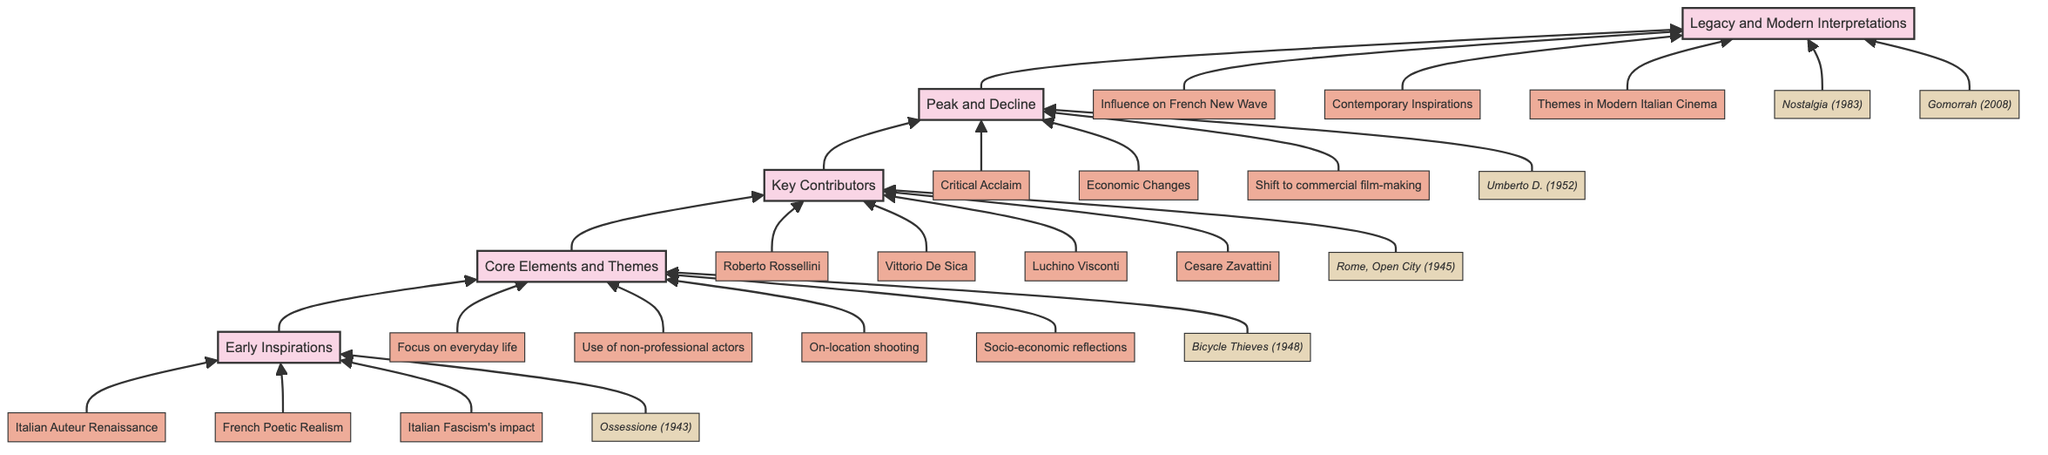What is the starting stage in the diagram? The first node at the bottom of the flow chart is "Early Inspirations," indicating it is the foundational stage for the development of Italian Neorealism.
Answer: Early Inspirations How many core themes are listed under "Core Elements and Themes"? The node "Core Elements and Themes" has four details listed beneath it, which encompass key characteristics of Italian Neorealism.
Answer: 4 Which film is associated with the "Key Contributors" stage? The diagram notes "Rome, Open City" as an example film within the "Key Contributors" stage, linking a specific film to its influential creators.
Answer: Rome, Open City What is the final stage of the described development? The topmost node in the diagram is "Legacy and Modern Interpretations," signifying it as the concluding phase of the flow.
Answer: Legacy and Modern Interpretations Which themes influenced the modern interpretations as noted in the final stage? The final stage underscores three main points: "Influence on French New Wave," "Contemporary Directors Drawing Inspiration," and "Themes in Modern Italian Cinema," indicating the specific thematic legacies of Neorealism.
Answer: Influence on French New Wave, Contemporary Directors Drawing Inspiration, Themes in Modern Italian Cinema What relationship exists between "Core Elements and Themes" and "Key Contributors"? The flow of the diagram indicates that "Core Elements and Themes" directly leads to "Key Contributors," illustrating that these thematic elements are shaped and defined by the mentioned filmmakers.
Answer: Direct influence In which year was "Bicycle Thieves" released? The example provided beneath the "Core Elements and Themes" stage points directly to "Bicycle Thieves," which is explicitly labeled as having been released in 1948.
Answer: 1948 How does "Peak and Decline" relate to "Legacy and Modern Interpretations"? The diagram shows a direct upward flow from "Peak and Decline" to "Legacy and Modern Interpretations," suggesting that the changes and outcomes of the Peak stage directly inform the later interpretive stage.
Answer: Direct upward flow Name one director mentioned in the "Key Contributors" section. Among the listed key contributors, "Roberto Rossellini" is explicitly noted, representing one of the significant filmmakers of Italian Neorealism.
Answer: Roberto Rossellini 